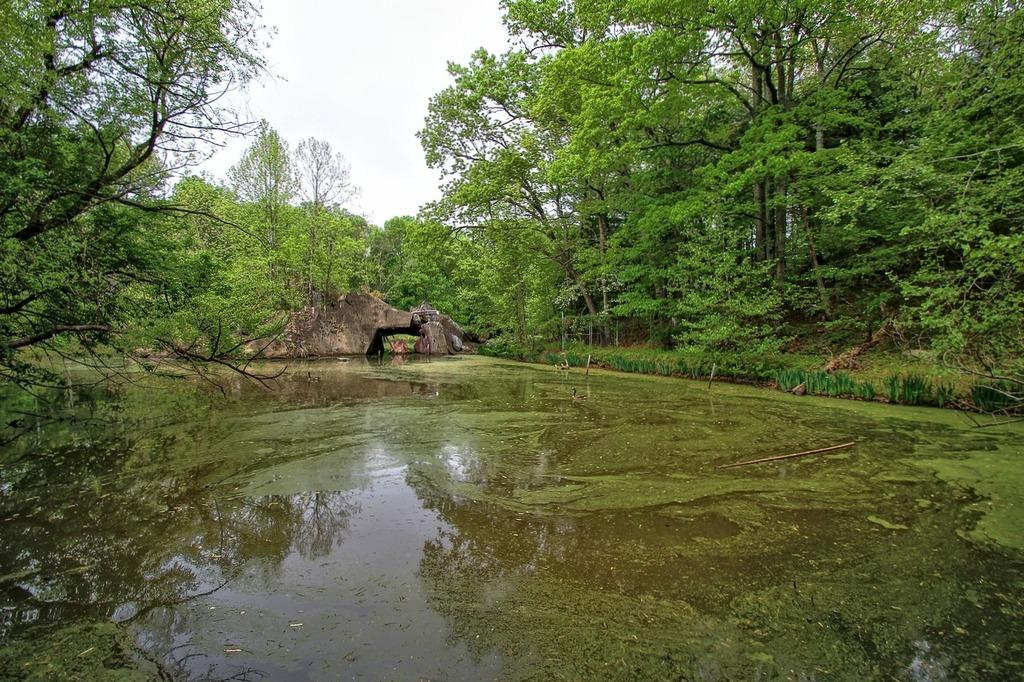What is the primary element visible in the image? There is water in the image. What other objects can be seen in the image? There are stones and trees on either side of the image. What can be seen in the background of the image? The sky is visible in the background of the image. What type of suit is the yak wearing in the image? There is no yak present in the image, and therefore no suit can be observed. 